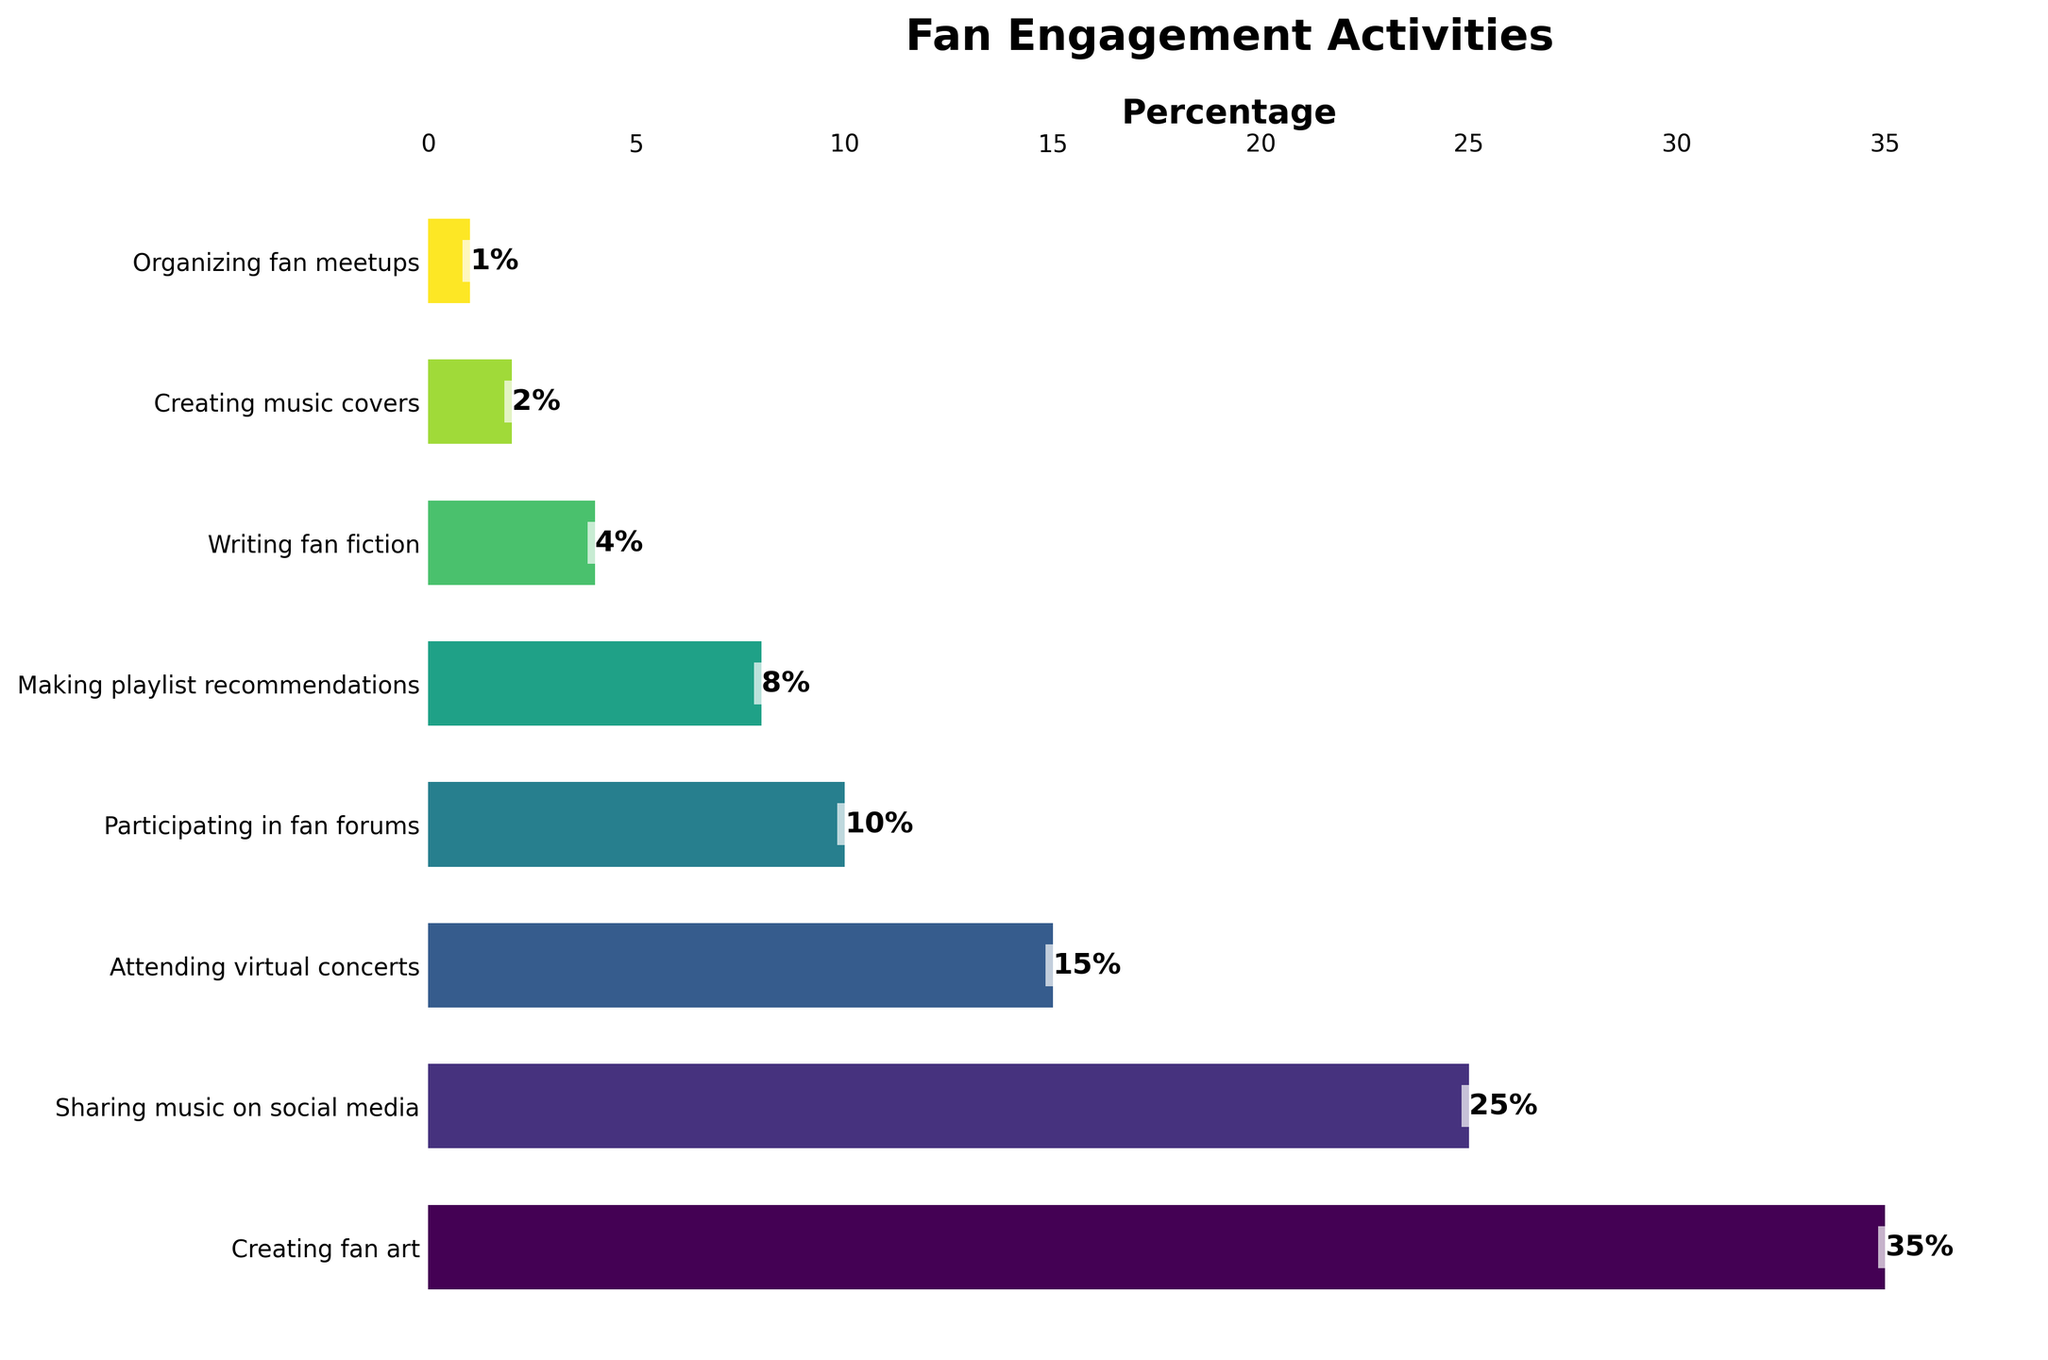Which activity has the highest percentage of time spent? The bar representing "Creating fan art" is the longest on the horizontal bar chart, indicating that it has the highest percentage at 35%.
Answer: Creating fan art What is the combined percentage of time spent on "Writing fan fiction" and "Creating music covers"? Add the percentages for "Writing fan fiction" (4%) and "Creating music covers" (2%). 4% + 2% = 6%.
Answer: 6% How much more time is spent on "Sharing music on social media" compared to "Attending virtual concerts"? Subtract the percentage of "Attending virtual concerts" (15%) from "Sharing music on social media" (25%). 25% - 15% = 10%.
Answer: 10% What is the total percentage of time spent on "Making playlist recommendations," "Writing fan fiction," and "Organizing fan meetups" combined? Sum the percentages of "Making playlist recommendations" (8%), "Writing fan fiction" (4%), and "Organizing fan meetups" (1%). 8% + 4% + 1% = 13%.
Answer: 13% Which two activities have the smallest percentages of time spent? The shortest bars on the chart represent the smallest percentages, which are "Organizing fan meetups" (1%) and "Creating music covers" (2%).
Answer: Organizing fan meetups and Creating music covers Is the percentage of time spent on "Participating in fan forums" greater than, less than, or equal to that of "Attending virtual concerts"? Compare the lengths of the bars for "Participating in fan forums" (10%) and "Attending virtual concerts" (15%). 10% is less than 15%.
Answer: Less than Which activity is represented by the bar just above "Making playlist recommendations" in terms of percentage? The bar just above "Making playlist recommendations" (8%) represents "Participating in fan forums" with a percentage of 10%.
Answer: Participating in fan forums What is the range of percentages for the activities shown? To find the range, subtract the smallest percentage value (1% for "Organizing fan meetups") from the largest percentage value (35% for "Creating fan art"). 35% - 1% = 34%.
Answer: 34% How many activities have a percentage of time spent that is 10% or more? Identify the activities with percentages ≥ 10%: "Creating fan art" (35%), "Sharing music on social media" (25%), "Attending virtual concerts" (15%), and "Participating in fan forums" (10%). There are four activities.
Answer: Four What is the average percentage of time spent on "Creating fan art," "Sharing music on social media," and "Attending virtual concerts"? Add the percentages for the three activities: 35% + 25% + 15% = 75%. Then divide by 3 to get the average: 75% / 3 = 25%.
Answer: 25% 